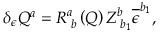<formula> <loc_0><loc_0><loc_500><loc_500>\delta _ { \epsilon } Q ^ { a } = R _ { \, b } ^ { a } \left ( Q \right ) Z _ { \, b _ { 1 } } ^ { b } \overline { \epsilon } ^ { b _ { 1 } } ,</formula> 